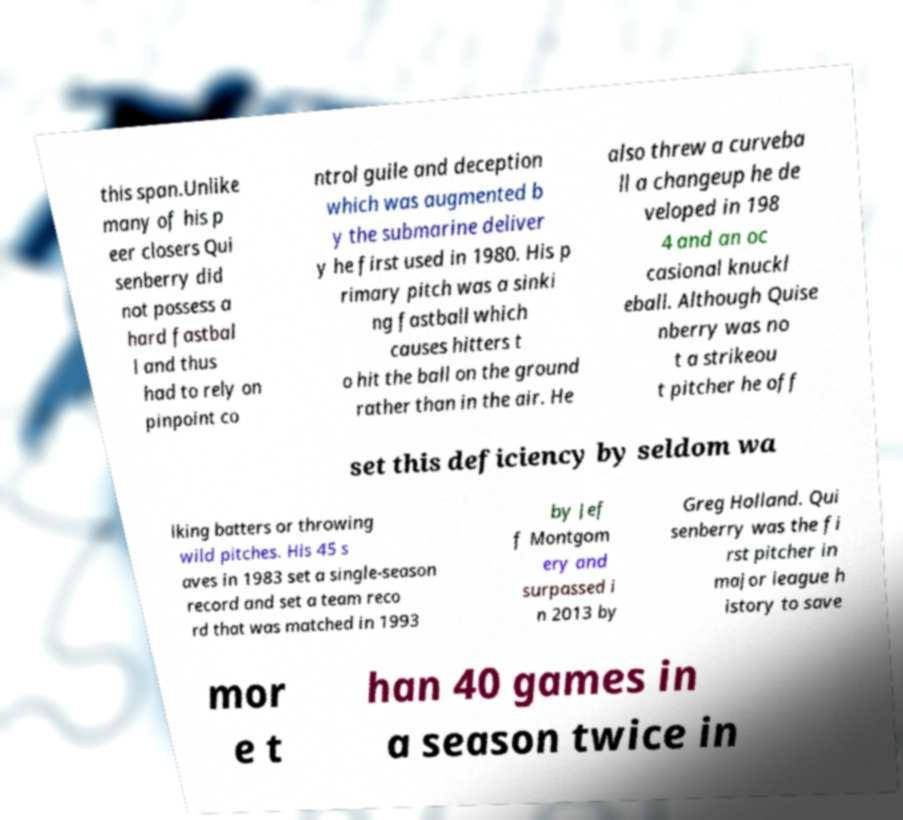There's text embedded in this image that I need extracted. Can you transcribe it verbatim? this span.Unlike many of his p eer closers Qui senberry did not possess a hard fastbal l and thus had to rely on pinpoint co ntrol guile and deception which was augmented b y the submarine deliver y he first used in 1980. His p rimary pitch was a sinki ng fastball which causes hitters t o hit the ball on the ground rather than in the air. He also threw a curveba ll a changeup he de veloped in 198 4 and an oc casional knuckl eball. Although Quise nberry was no t a strikeou t pitcher he off set this deficiency by seldom wa lking batters or throwing wild pitches. His 45 s aves in 1983 set a single-season record and set a team reco rd that was matched in 1993 by Jef f Montgom ery and surpassed i n 2013 by Greg Holland. Qui senberry was the fi rst pitcher in major league h istory to save mor e t han 40 games in a season twice in 